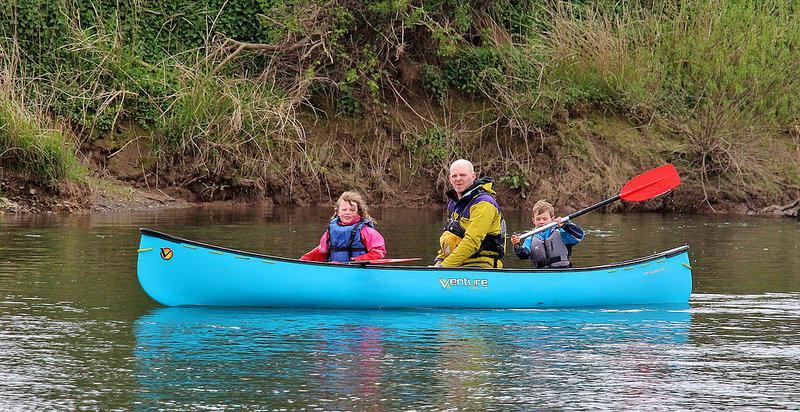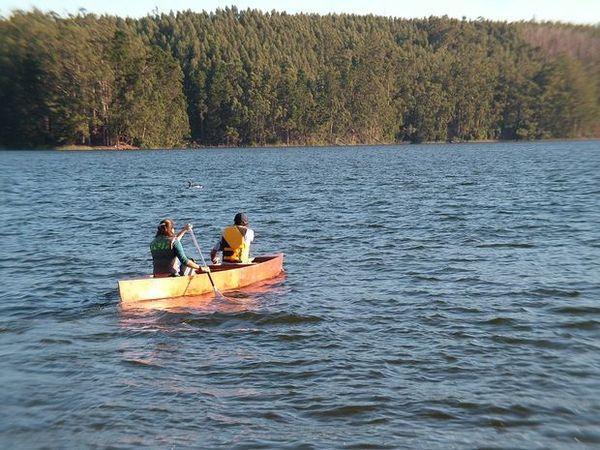The first image is the image on the left, the second image is the image on the right. Given the left and right images, does the statement "There is exactly one boat in the image on the right." hold true? Answer yes or no. Yes. 